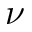<formula> <loc_0><loc_0><loc_500><loc_500>\nu</formula> 